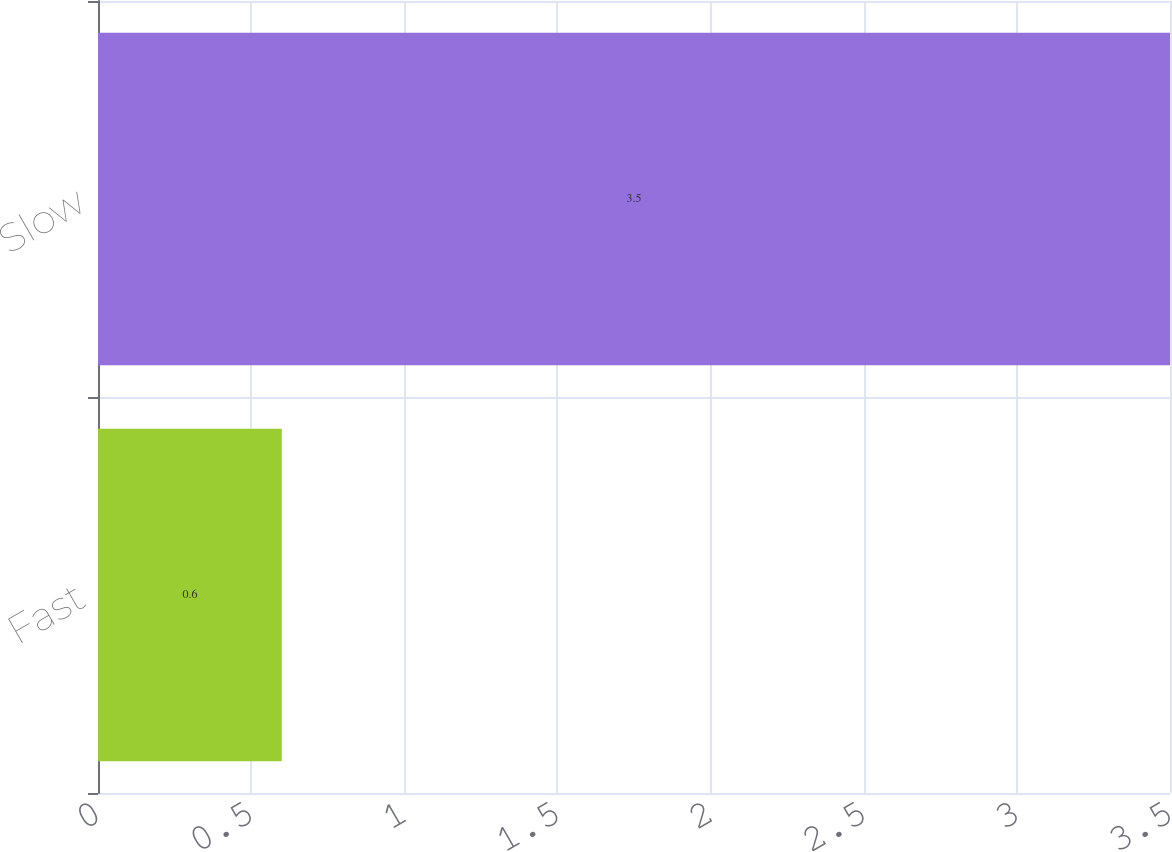Convert chart to OTSL. <chart><loc_0><loc_0><loc_500><loc_500><bar_chart><fcel>Fast<fcel>Slow<nl><fcel>0.6<fcel>3.5<nl></chart> 